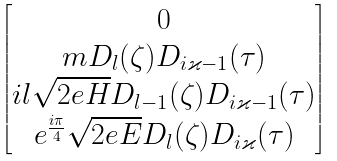<formula> <loc_0><loc_0><loc_500><loc_500>\begin{bmatrix} 0 \\ m D _ { l } ( \zeta ) D _ { i \varkappa - 1 } ( \tau ) \\ i l \sqrt { 2 e H } D _ { l - 1 } ( \zeta ) D _ { i \varkappa - 1 } ( \tau ) \\ e ^ { \frac { i \pi } 4 } \sqrt { 2 e E } D _ { l } ( \zeta ) D _ { i \varkappa } ( \tau ) \end{bmatrix}</formula> 